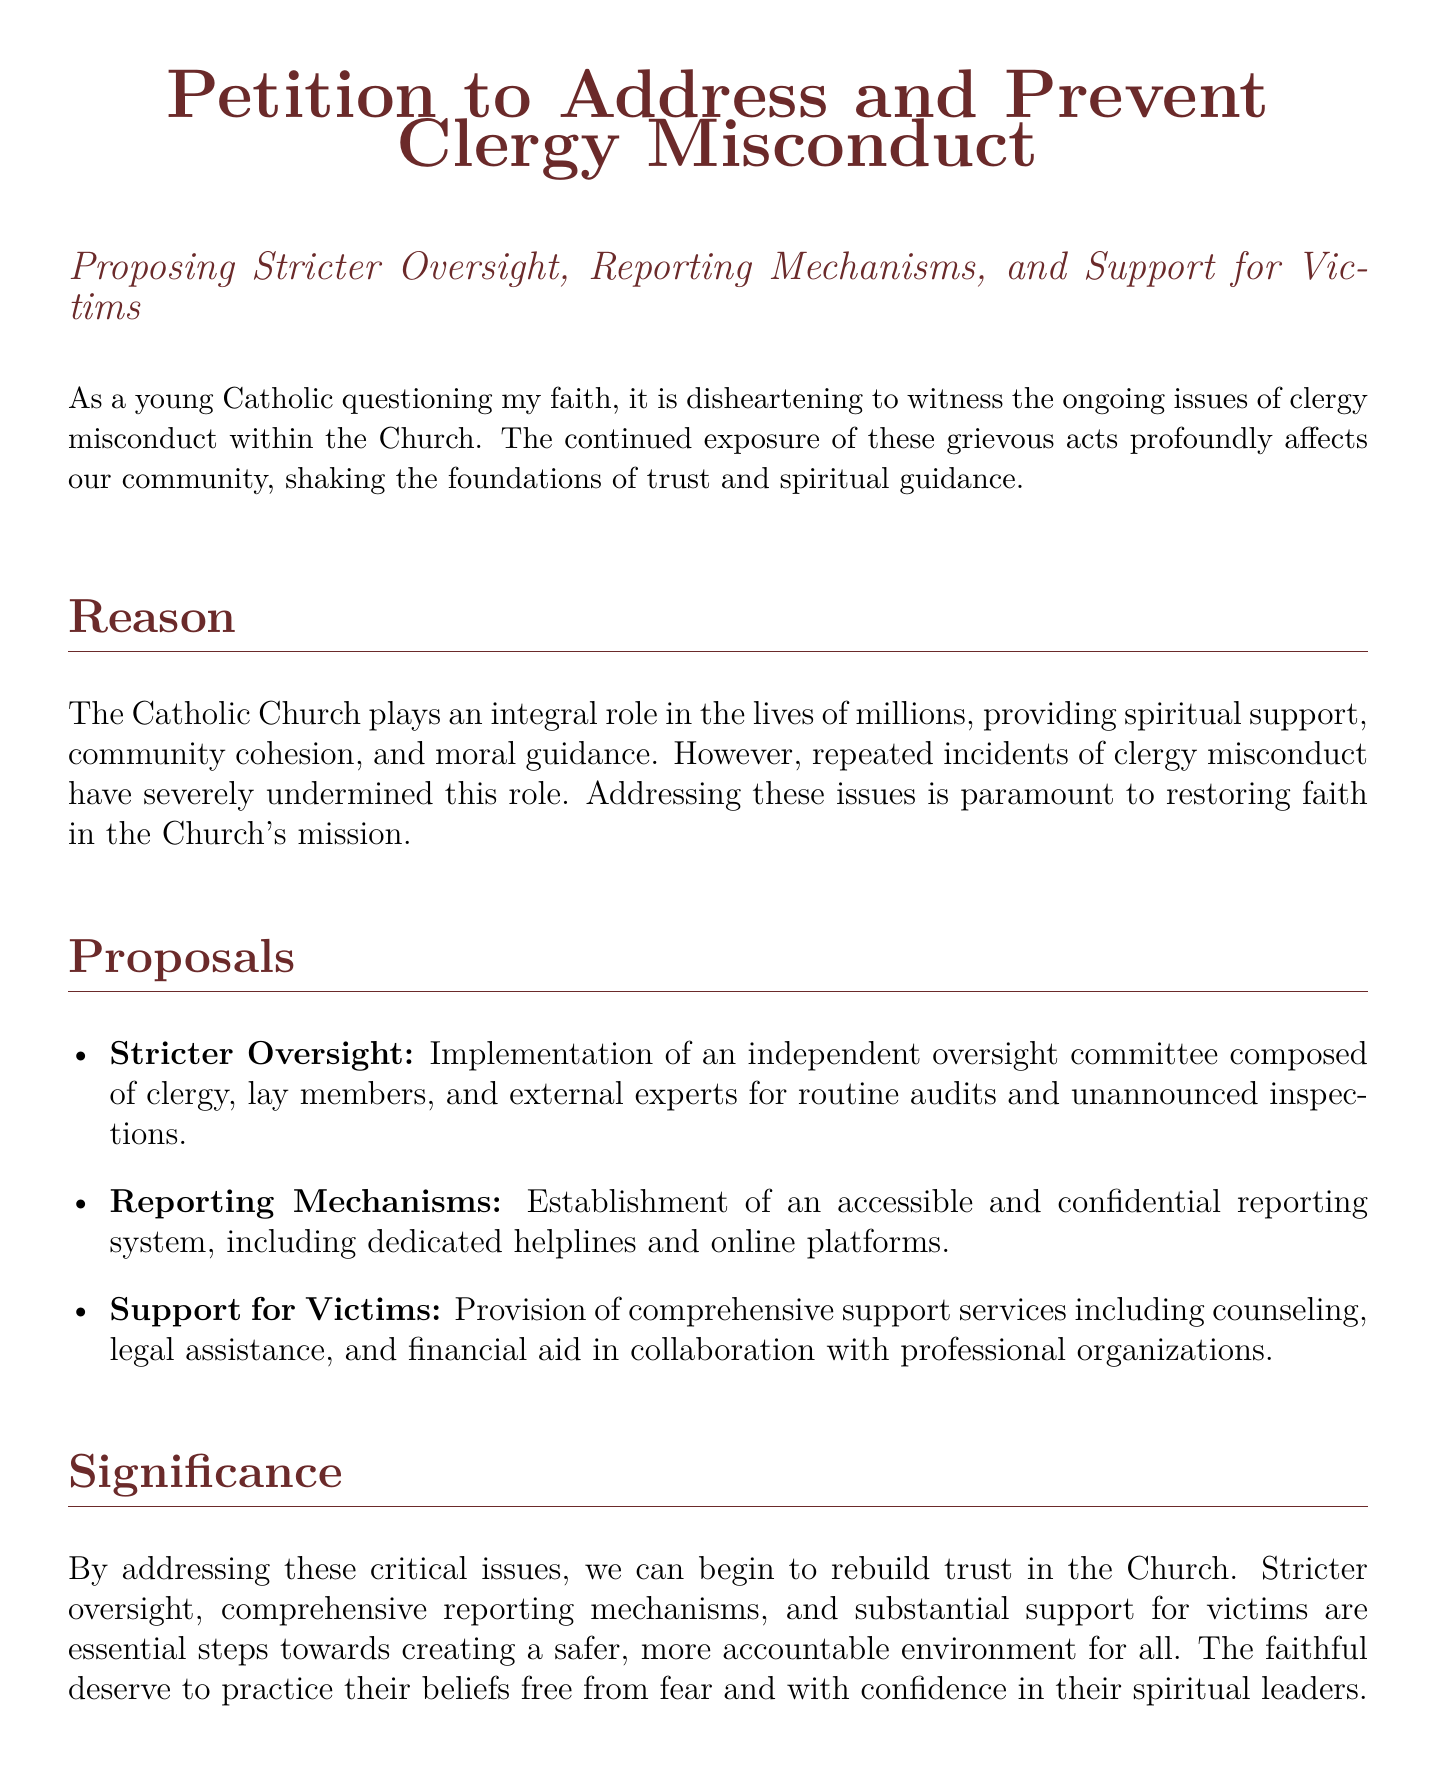What is the title of the document? The title is explicitly stated at the beginning of the document, which identifies its purpose.
Answer: Petition to Address and Prevent Clergy Misconduct What color is used for the main text? The document specifies the colors used in its formatting, particularly for headings and body text.
Answer: Black What is one of the proposals listed in the document? The document includes specific proposals aimed at addressing the issues of clergy misconduct.
Answer: Stricter Oversight How many proposals are mentioned in the document? The document lists proposals in a bulleted format, allowing for a clear count of the suggestions made.
Answer: Three What is the primary reason stated for the petition? The document outlines the critical need for addressing misconduct to restore trust and faith in the Church's mission.
Answer: To restore faith in the Church's mission What type of committee is proposed for oversight? The document denotes the type of committee intended to ensure accountability and oversight within the Church.
Answer: Independent oversight committee What does the document urge the Catholic Church leadership to do? The conclusion asserts a clear call to action for church officials regarding the proposals presented.
Answer: Adopt these proposals immediately What should victims receive according to the petition? The document emphasizes the necessity of support for victims of clergy misconduct, detailing what kind of assistance is to be provided.
Answer: Comprehensive support services 